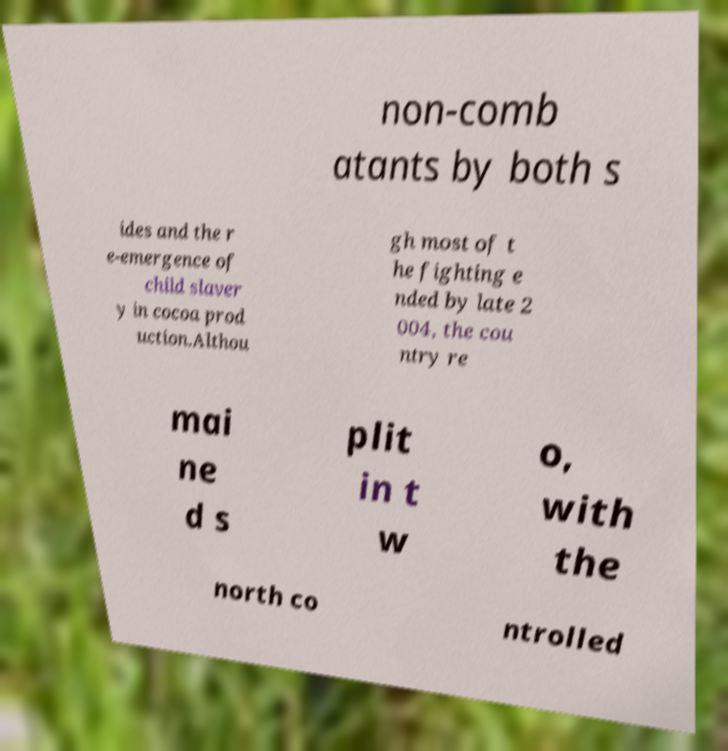Could you extract and type out the text from this image? non-comb atants by both s ides and the r e-emergence of child slaver y in cocoa prod uction.Althou gh most of t he fighting e nded by late 2 004, the cou ntry re mai ne d s plit in t w o, with the north co ntrolled 